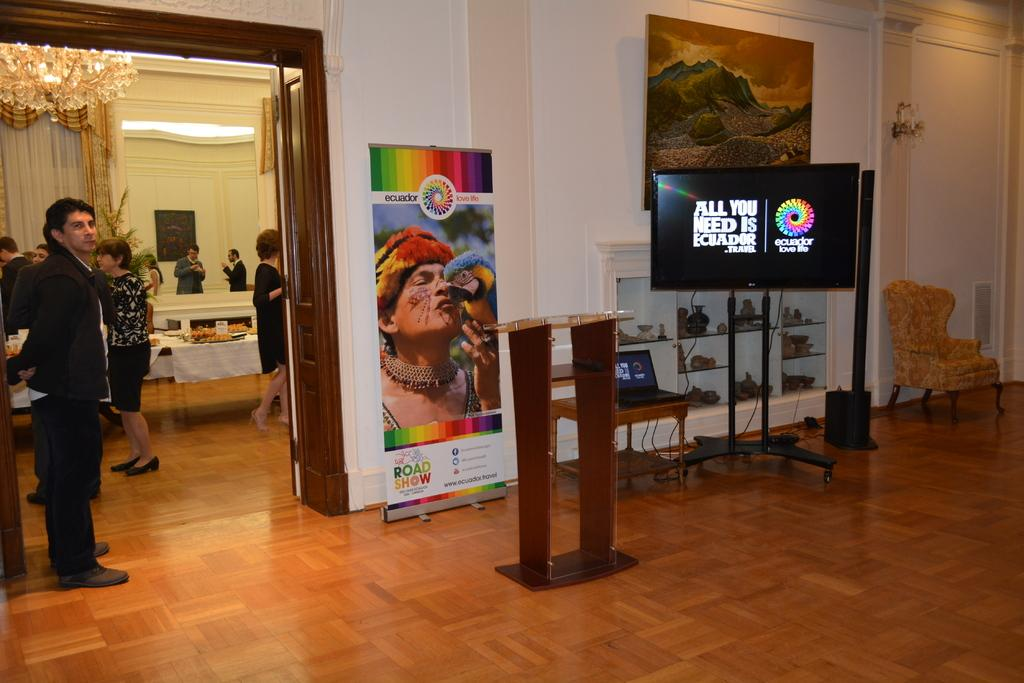<image>
Give a short and clear explanation of the subsequent image. Event with pictures and food to showcase Ecuador and talk about it. 